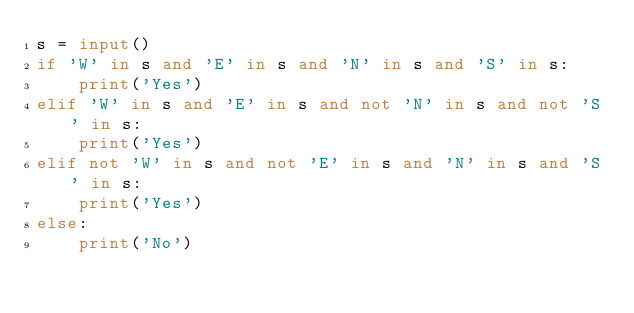<code> <loc_0><loc_0><loc_500><loc_500><_Python_>s = input()
if 'W' in s and 'E' in s and 'N' in s and 'S' in s:
    print('Yes')
elif 'W' in s and 'E' in s and not 'N' in s and not 'S' in s:
    print('Yes')
elif not 'W' in s and not 'E' in s and 'N' in s and 'S' in s:
    print('Yes')
else:
    print('No')
</code> 